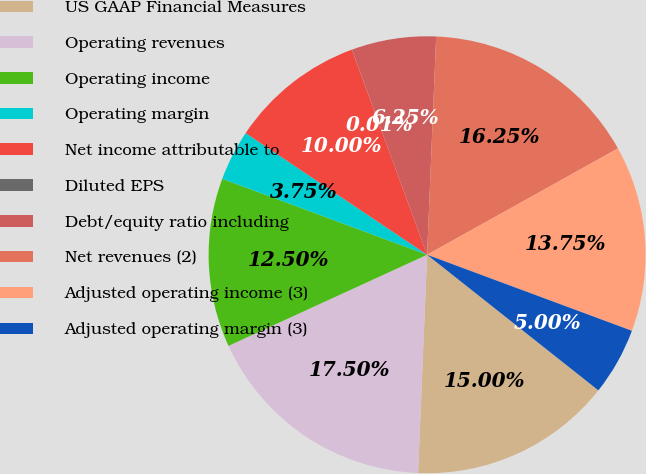Convert chart. <chart><loc_0><loc_0><loc_500><loc_500><pie_chart><fcel>US GAAP Financial Measures<fcel>Operating revenues<fcel>Operating income<fcel>Operating margin<fcel>Net income attributable to<fcel>Diluted EPS<fcel>Debt/equity ratio including<fcel>Net revenues (2)<fcel>Adjusted operating income (3)<fcel>Adjusted operating margin (3)<nl><fcel>15.0%<fcel>17.5%<fcel>12.5%<fcel>3.75%<fcel>10.0%<fcel>0.01%<fcel>6.25%<fcel>16.25%<fcel>13.75%<fcel>5.0%<nl></chart> 